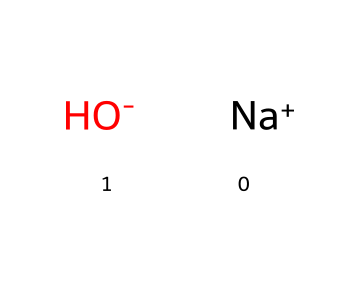What is the name of this chemical? The chemical represented by the SMILES notation [Na+].[OH-] is composed of sodium and hydroxide ions, which combine to form sodium hydroxide.
Answer: sodium hydroxide How many atoms are present in this chemical? The chemical consists of one sodium atom and one oxygen atom (from hydroxide), along with one hydrogen atom; thus, there are three atoms in total.
Answer: three What charge does the sodium ion carry? The sodium ion is represented as [Na+], indicating it has a positive charge.
Answer: positive What is the pH nature of sodium hydroxide? Sodium hydroxide is a strong base and typically has a high pH, indicating it is alkaline in nature.
Answer: alkaline Which ion indicates that this chemical is basic? The presence of the hydroxide ion (OH-) indicates that the chemical is basic, as hydroxide ions are characteristic of bases.
Answer: hydroxide What is the significance of sodium hydroxide in cleaning applications? Sodium hydroxide is often used in cleaning solutions due to its ability to dissolve grease and organic matter.
Answer: dissolving grease Is sodium hydroxide soluble in water? Yes, sodium hydroxide is highly soluble in water, which makes it effective for cleaning and other applications.
Answer: highly soluble 